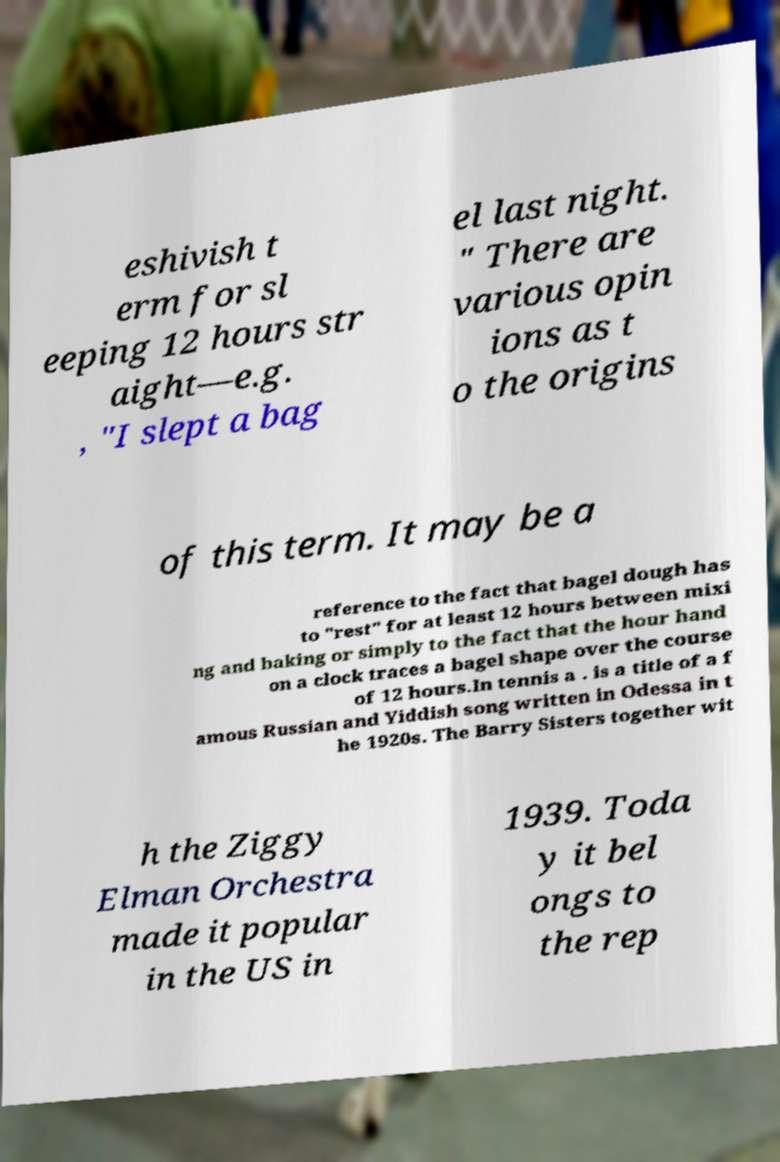Please read and relay the text visible in this image. What does it say? eshivish t erm for sl eeping 12 hours str aight—e.g. , "I slept a bag el last night. " There are various opin ions as t o the origins of this term. It may be a reference to the fact that bagel dough has to "rest" for at least 12 hours between mixi ng and baking or simply to the fact that the hour hand on a clock traces a bagel shape over the course of 12 hours.In tennis a . is a title of a f amous Russian and Yiddish song written in Odessa in t he 1920s. The Barry Sisters together wit h the Ziggy Elman Orchestra made it popular in the US in 1939. Toda y it bel ongs to the rep 